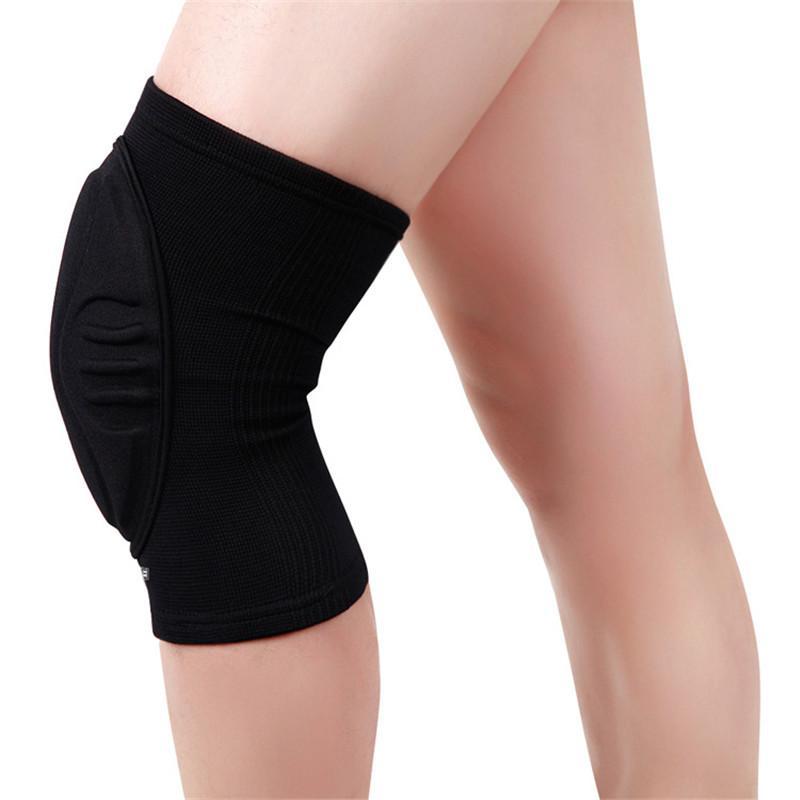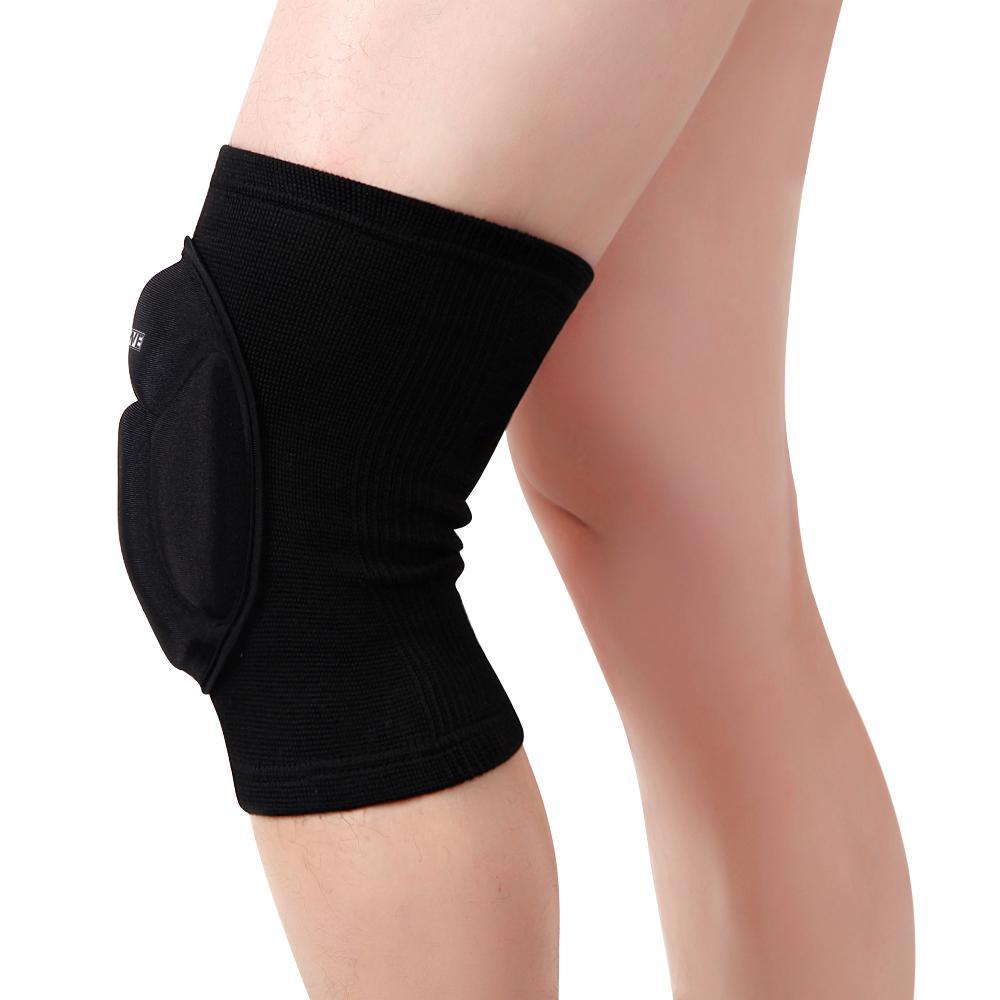The first image is the image on the left, the second image is the image on the right. Evaluate the accuracy of this statement regarding the images: "Each image shows a pair of legs, with just one leg wearing a black knee wrap.". Is it true? Answer yes or no. Yes. The first image is the image on the left, the second image is the image on the right. For the images displayed, is the sentence "The left and right image contains a total of two knee braces." factually correct? Answer yes or no. Yes. 